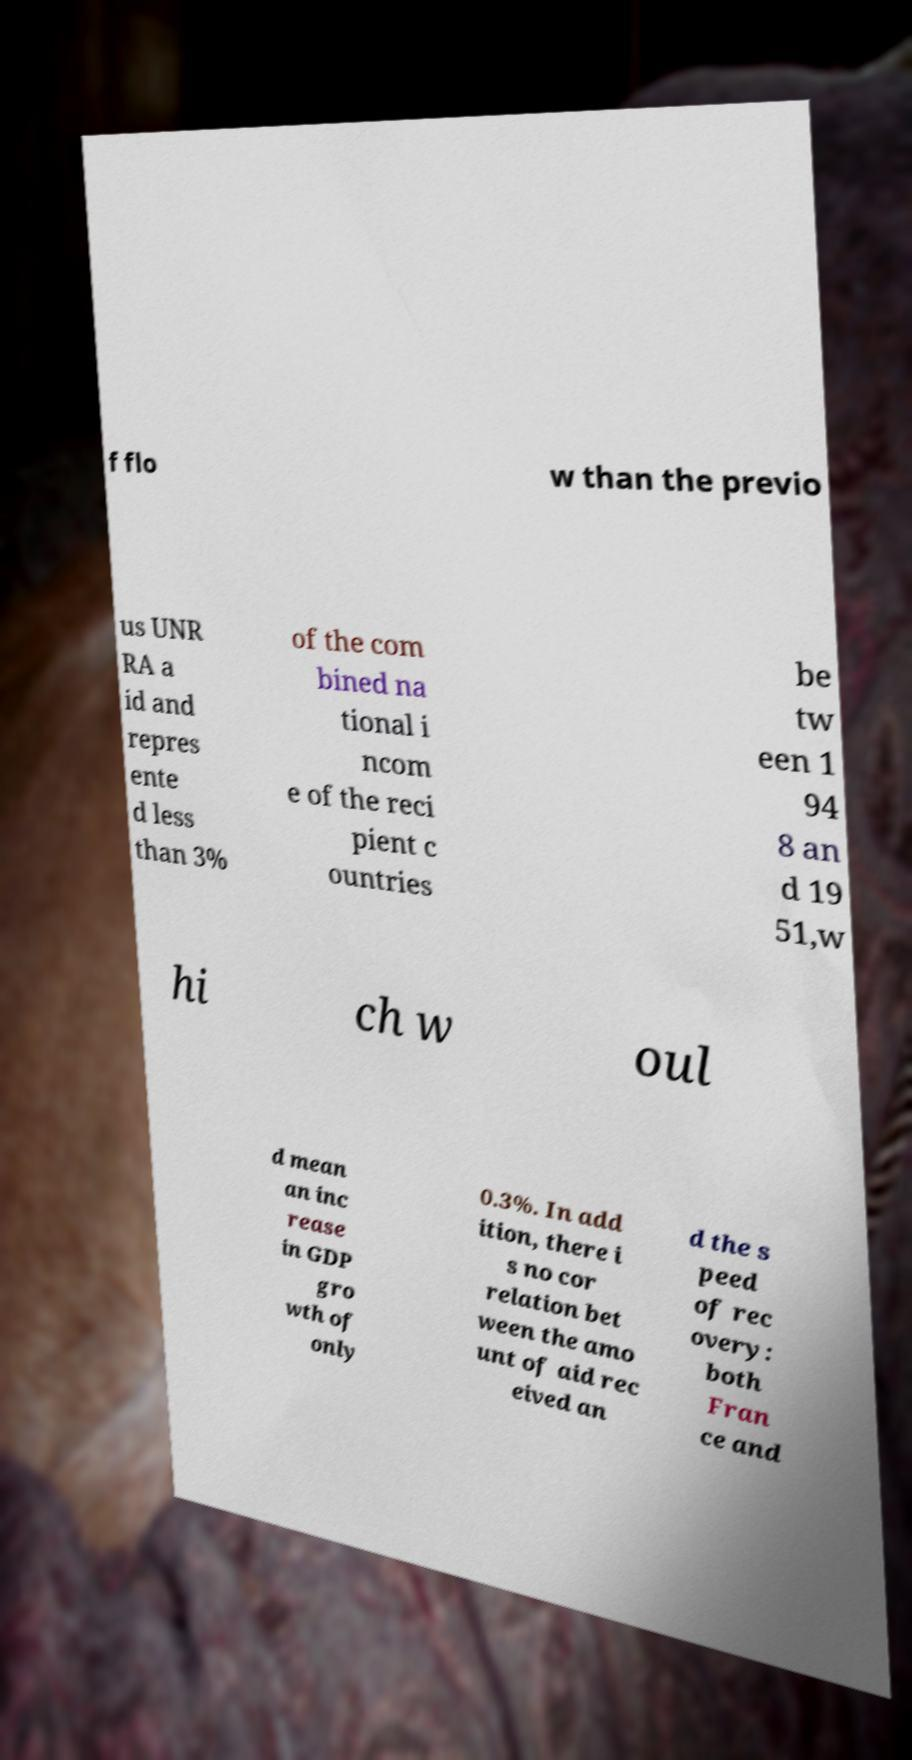Could you extract and type out the text from this image? f flo w than the previo us UNR RA a id and repres ente d less than 3% of the com bined na tional i ncom e of the reci pient c ountries be tw een 1 94 8 an d 19 51,w hi ch w oul d mean an inc rease in GDP gro wth of only 0.3%. In add ition, there i s no cor relation bet ween the amo unt of aid rec eived an d the s peed of rec overy: both Fran ce and 